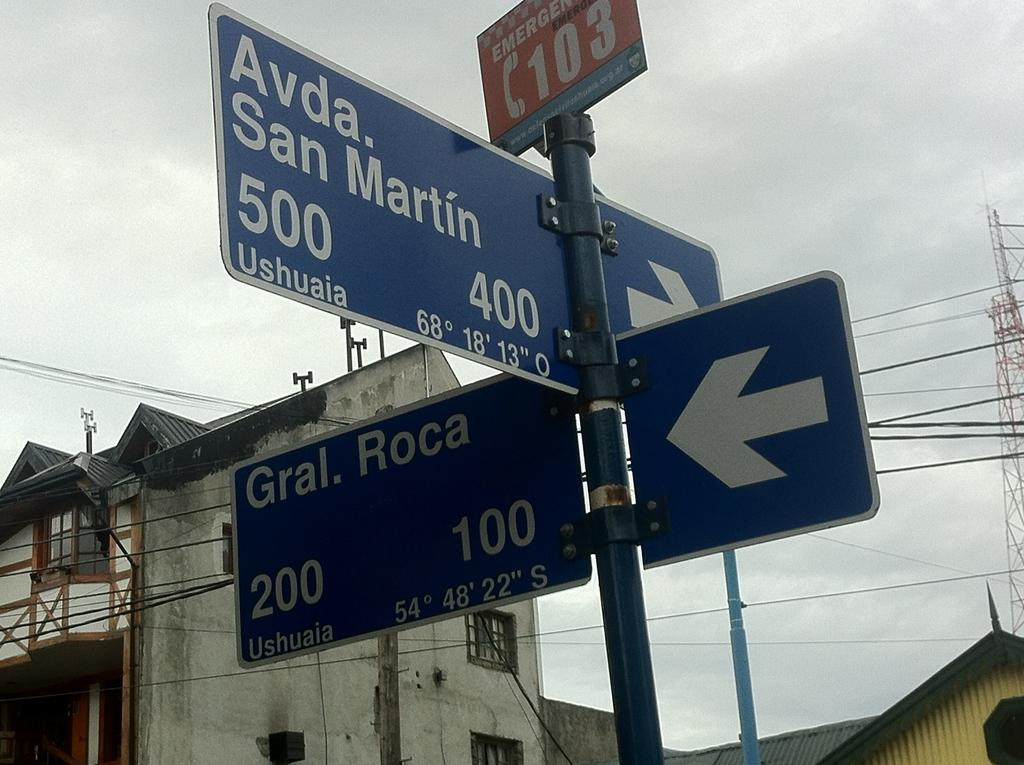<image>
Describe the image concisely. A navigation sign at the corner of Avda. San Martin and Gral. Roca. 